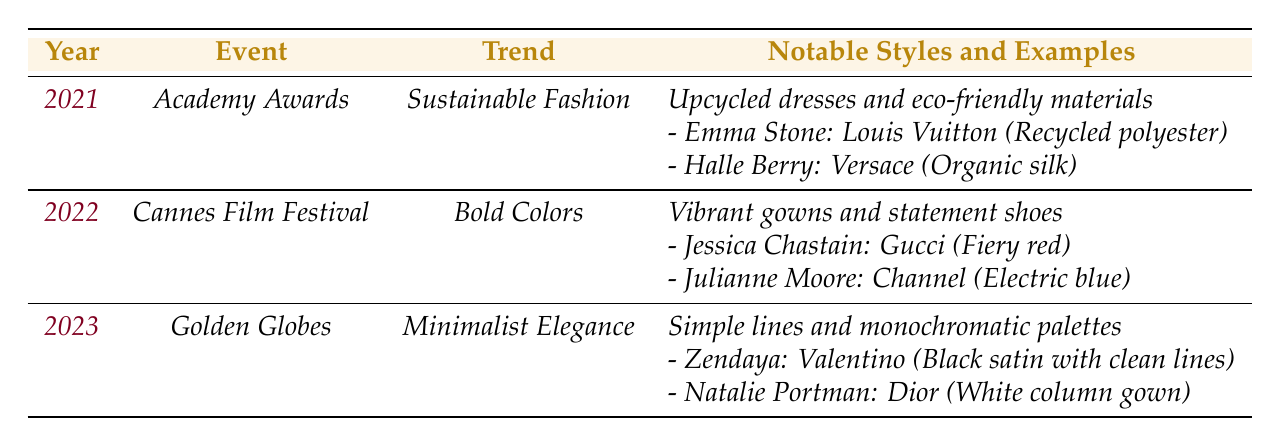What fashion trend was prominent at the Academy Awards in 2021? The table shows that the trend at the Academy Awards in 2021 was "Sustainable Fashion."
Answer: Sustainable Fashion Which actress wore a dress made from organic silk at the Academy Awards in 2021? According to the table, Halle Berry wore a dress designed by Versace made from organic silk at the Academy Awards in 2021.
Answer: Halle Berry Which event featured the bold colors trend in 2022? The table indicates that the Cannes Film Festival showcased the bold colors trend in 2022.
Answer: Cannes Film Festival How many notable styles are listed for the Golden Globes in 2023? The table lists two notable styles for the Golden Globes in 2023: "Simple lines" and "monochromatic palettes," and provides two examples of actresses with their respective dresses.
Answer: 2 Did Zendaya wear a colorful dress at the Golden Globes in 2023? The table states that Zendaya wore a black satin dress with clean lines, which is minimalistic; therefore, she did not wear a colorful dress.
Answer: No What material did Emma Stone's dress at the Academy Awards utilize? The table specifies that Emma Stone's dress was made from recycled polyester, an eco-friendly material, at the Academy Awards in 2021.
Answer: Recycled polyester Which trend had the most notable styles listed in the table? Comparing the notable styles listed, both Sustainable Fashion and Bold Colors have similar notable styles, but Bold Colors lists specific examples of vibrant gowns, making it more detailed. However, for simple counting, both have lists of two.
Answer: Tie Name the actresses who wore dresses at the Cannes Film Festival in 2022 and specify their dress colors. The table documents that Jessica Chastain wore a fiery red dress by Gucci and Julianne Moore wore an electric blue dress by Channel at the Cannes Film Festival in 2022.
Answer: Jessica Chastain (fiery red), Julianne Moore (electric blue) What is the common theme of the fashion trends from 2021 to 2023? The table reveals that the trends from 2021 to 2023 are varied: Sustainable Fashion focuses on eco-friendliness, Bold Colors highlights vibrancy, and Minimalist Elegance emphasizes simplicity; thus, they encompass a progression from eco-friendly to bold expression to minimalism.
Answer: Varied themes Which year saw the introduction of Minimalist Elegance at an awards event? The table shows that Minimalist Elegance was introduced during the Golden Globes in 2023.
Answer: 2023 